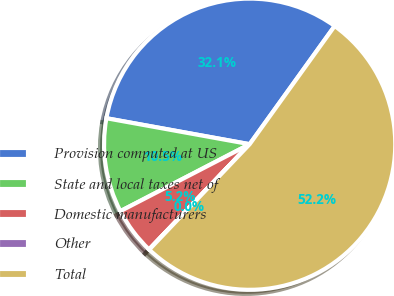Convert chart to OTSL. <chart><loc_0><loc_0><loc_500><loc_500><pie_chart><fcel>Provision computed at US<fcel>State and local taxes net of<fcel>Domestic manufacturers<fcel>Other<fcel>Total<nl><fcel>32.07%<fcel>10.46%<fcel>5.25%<fcel>0.03%<fcel>52.19%<nl></chart> 